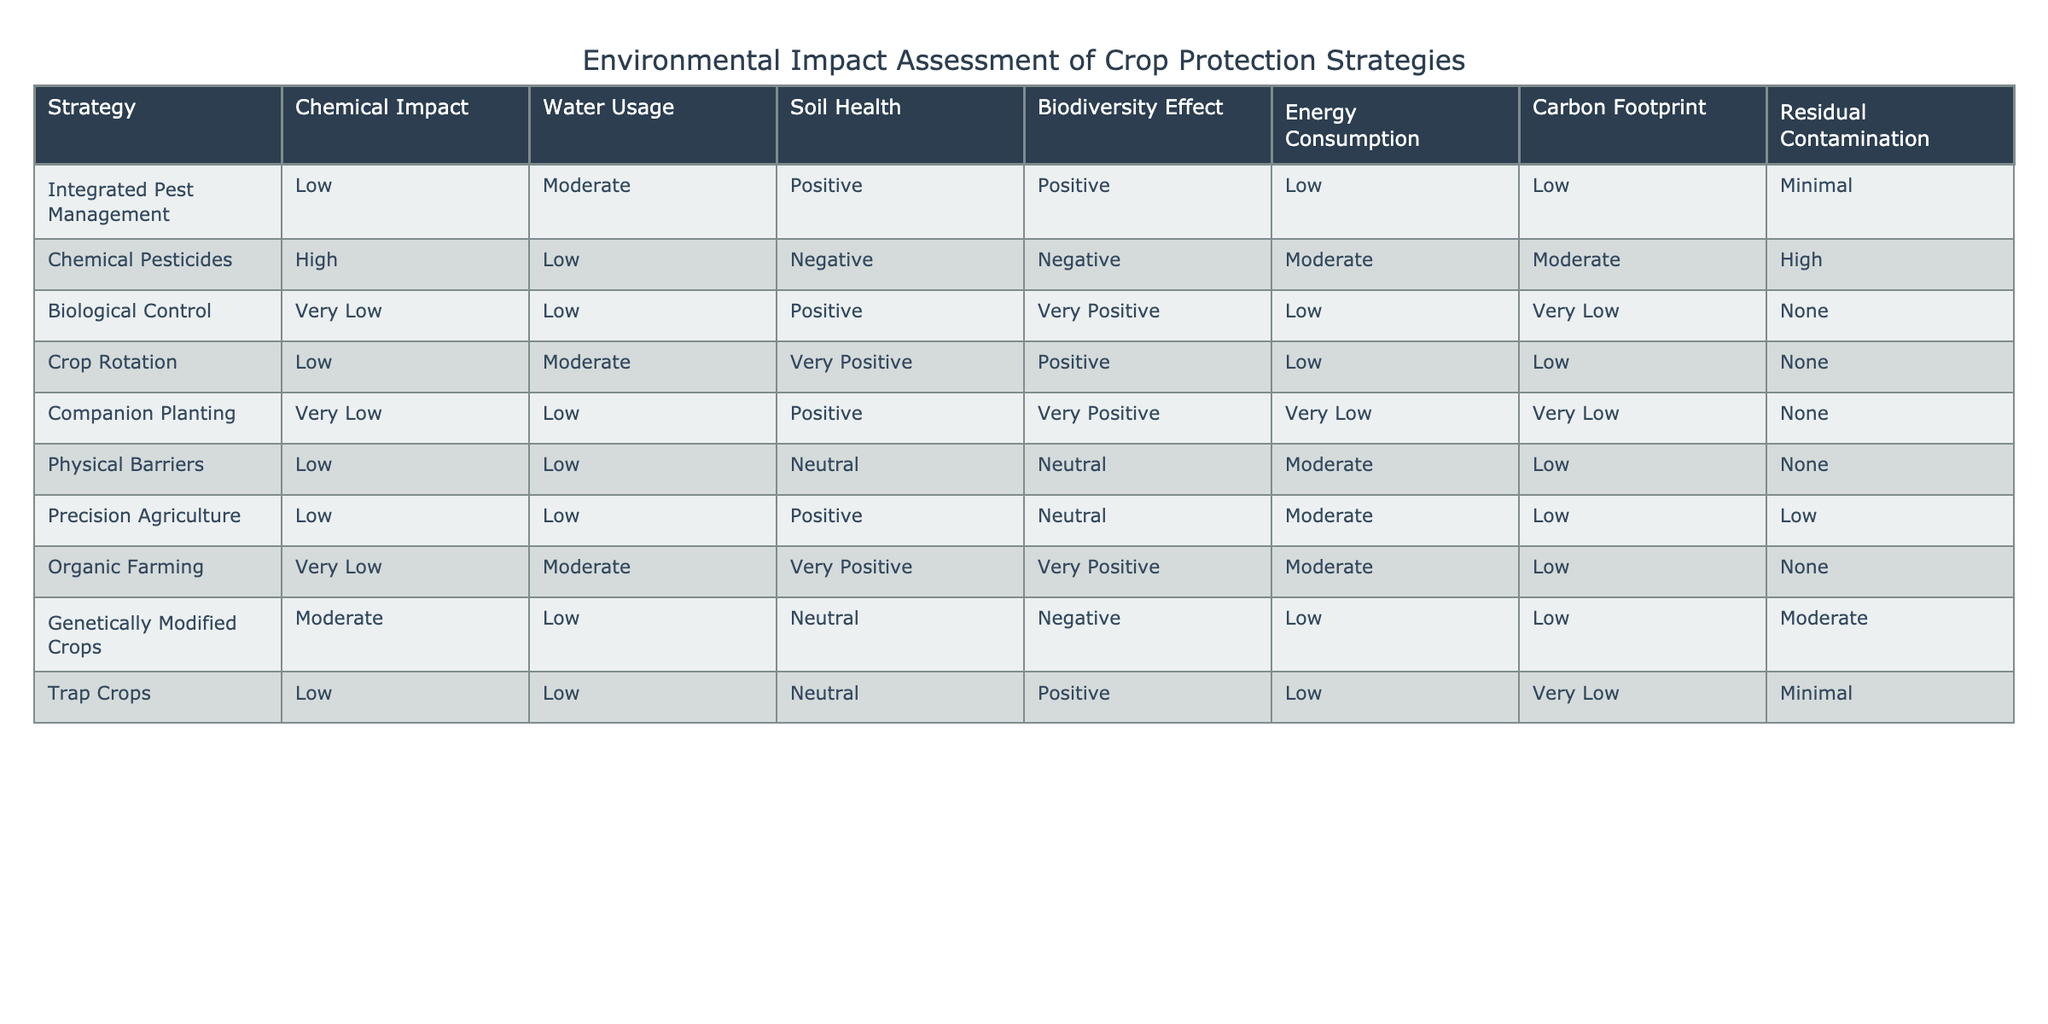What is the chemical impact level of biological control? In the table, the chemical impact level for biological control is listed as "Very Low." You can find this information directly in the row corresponding to biological control under the column labeled "Chemical Impact."
Answer: Very Low Which strategy has the highest carbon footprint? Scanning the "Carbon Footprint" column in the table, "Chemical Pesticides" shows a high carbon footprint while other strategies either have low, very low, or moderate levels. Therefore, chemical pesticides exhibit the highest carbon footprint among the listed strategies.
Answer: Chemical Pesticides How many strategies have a positive effect on biodiversity? By reviewing the "Biodiversity Effect" column, the strategies that have a positive effect are Integrated Pest Management, Crop Rotation, Companion Planting, Trap Crops, and Biological Control. Counting these entries results in a total of five strategies that positively affect biodiversity.
Answer: 5 Is it true that all strategies that use very low chemical impact also have low water usage? Checking the entries, Biological Control, Companion Planting, and Trap Crops all have "Very Low" chemical impact, but they do not consistently show "Low" water usage. Both Biological Control and Companion Planting have low water usage, while Trap Crops also have low water usage. Thus, this statement is true because all strategies with very low chemical impact mentioned also reflect low water usage.
Answer: Yes What is the average energy consumption of the strategies that produce positive effects on soil health? The strategies with positive effects on soil health are Integrated Pest Management, Biological Control, Crop Rotation, Companion Planting, and Precision Agriculture. Their "Energy Consumption" levels are Low (1), Low (1), Low (1), Very Low (0.5), and Moderate (2), respectively. Calculating the average requires summing these values, which results in 5.5 (1 + 1 + 1 + 0.5 + 2), dividing by the number of strategies, which is 5. Therefore, the average is 5.5 / 5 = 1.1.
Answer: 1.1 Which strategy has minimal residual contamination but moderate water usage? Referring to the table, Precision Agriculture has minimal residual contamination and shows moderate water usage. This means it is the only strategy that meets these specific criteria outlined in the question.
Answer: Precision Agriculture 